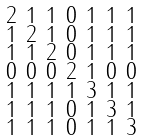Convert formula to latex. <formula><loc_0><loc_0><loc_500><loc_500>\begin{smallmatrix} 2 & 1 & 1 & 0 & 1 & 1 & 1 \\ 1 & 2 & 1 & 0 & 1 & 1 & 1 \\ 1 & 1 & 2 & 0 & 1 & 1 & 1 \\ 0 & 0 & 0 & 2 & 1 & 0 & 0 \\ 1 & 1 & 1 & 1 & 3 & 1 & 1 \\ 1 & 1 & 1 & 0 & 1 & 3 & 1 \\ 1 & 1 & 1 & 0 & 1 & 1 & 3 \end{smallmatrix}</formula> 